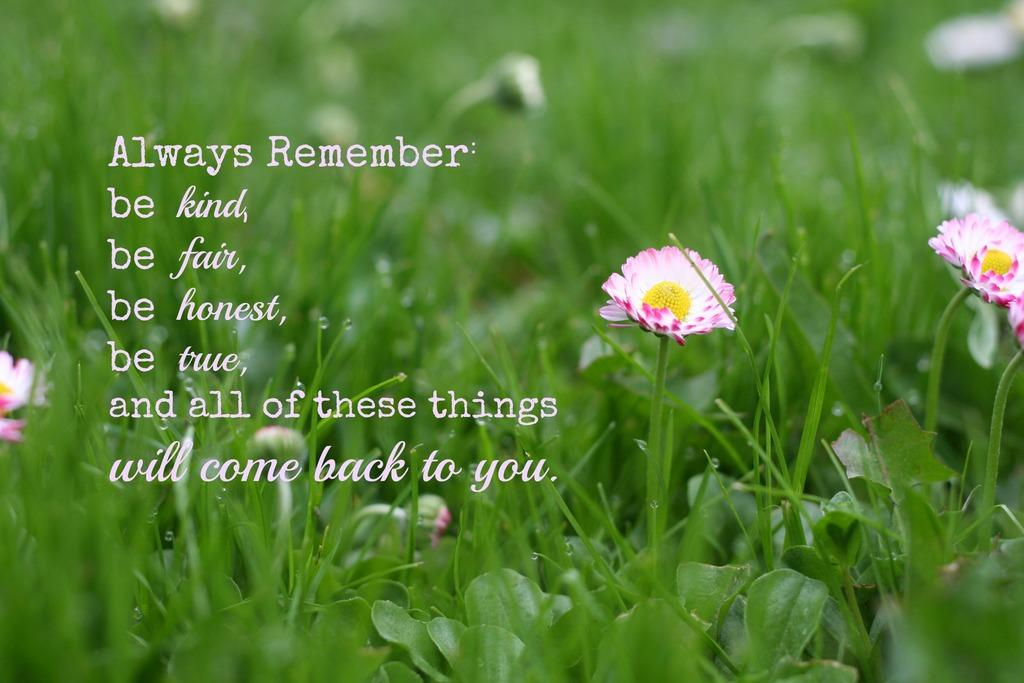What can be seen written on the image? There is something written on the image. What type of natural environment is visible in the image? There is grass visible in the image. What type of vegetation is present in the image? There are plants and flowers in the image. How would you describe the background of the image? The background of the image is blurred. What type of wool can be seen being spun by an owl in the image? There is no wool or owl present in the image. What type of noise can be heard coming from the flowers in the image? There is no noise coming from the flowers in the image, as flowers do not produce sound. 